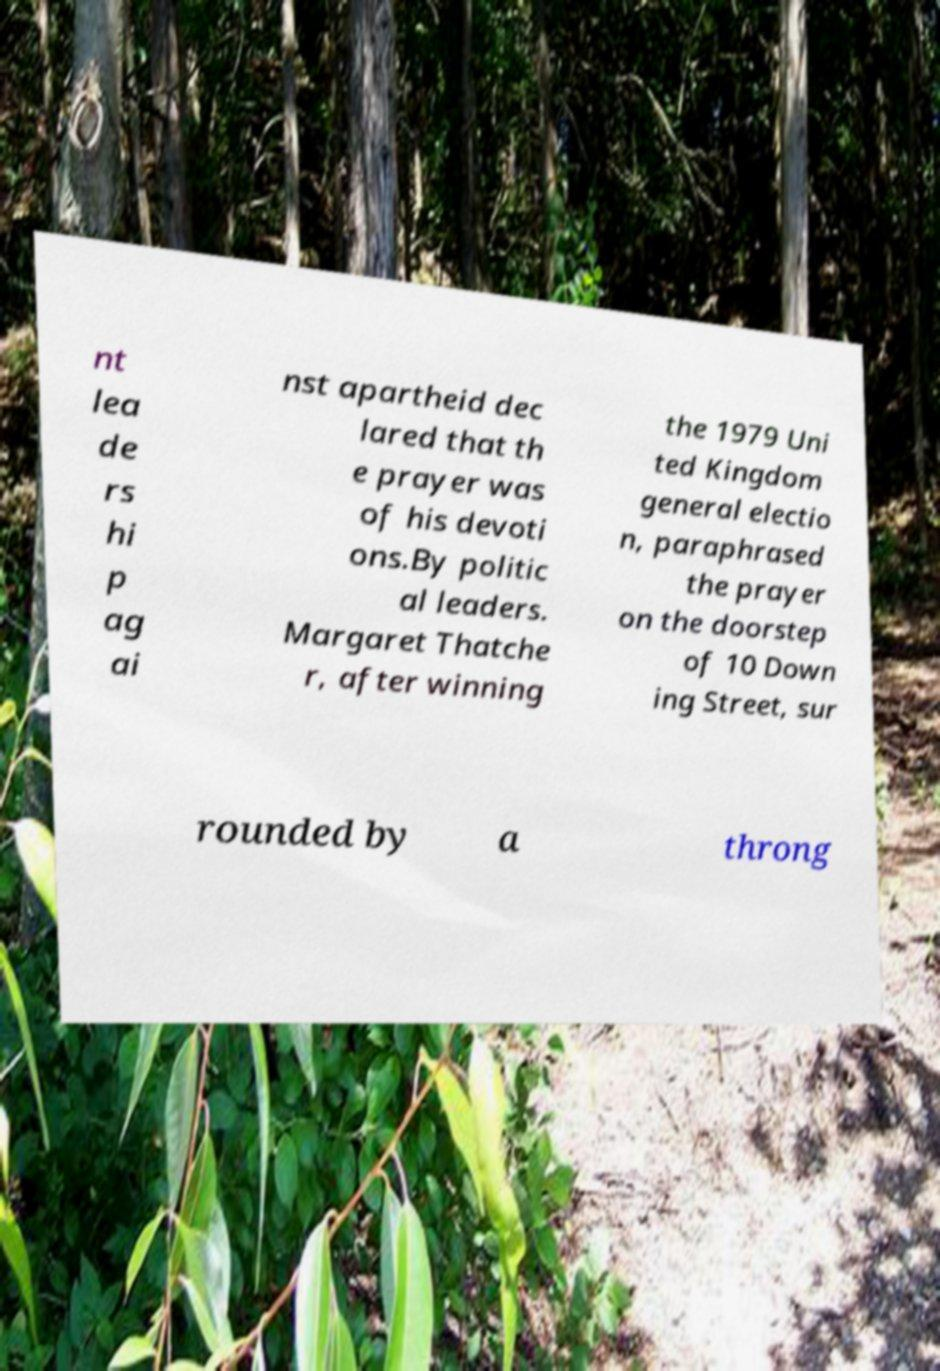I need the written content from this picture converted into text. Can you do that? nt lea de rs hi p ag ai nst apartheid dec lared that th e prayer was of his devoti ons.By politic al leaders. Margaret Thatche r, after winning the 1979 Uni ted Kingdom general electio n, paraphrased the prayer on the doorstep of 10 Down ing Street, sur rounded by a throng 